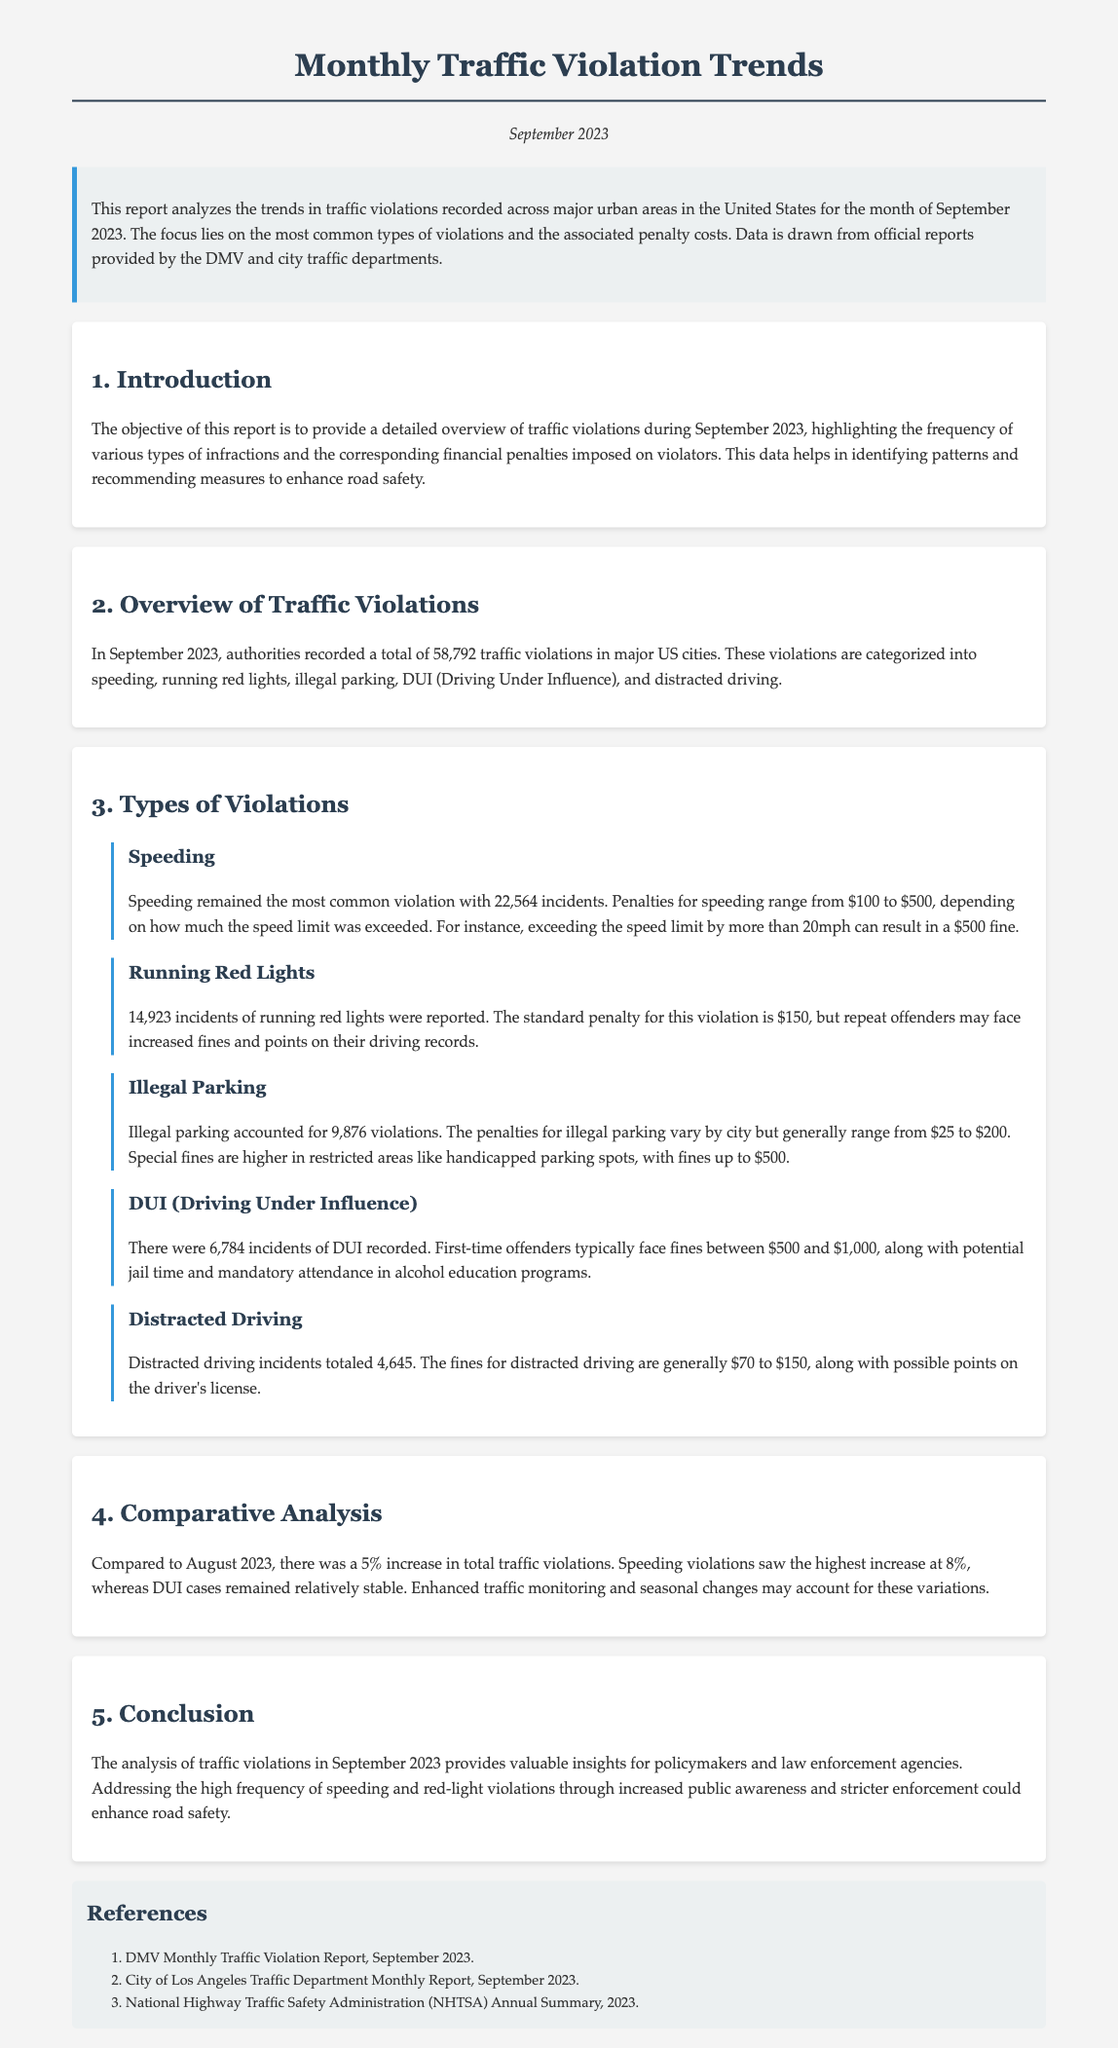What was the total number of traffic violations in September 2023? The total number of traffic violations recorded is stated in the document as 58,792.
Answer: 58,792 How many incidents of DUI were recorded? The document states that there were 6,784 incidents of DUI recorded in September 2023.
Answer: 6,784 What is the penalty range for speeding violations? The document specifies that penalties for speeding range from $100 to $500, depending on how much the speed limit was exceeded.
Answer: $100 to $500 Which type of violation had the highest number of incidents? The document identifies speeding as the most common violation with 22,564 incidents.
Answer: Speeding What percentage increase in total traffic violations was observed compared to August 2023? The report indicates a 5% increase in total traffic violations compared to August 2023.
Answer: 5% What are the penalties for illegal parking? The penalties for illegal parking vary but generally range from $25 to $200, with higher fines in restricted areas.
Answer: $25 to $200 How many incidents of running red lights were reported? The report mentions that there were 14,923 incidents of running red lights recorded.
Answer: 14,923 What specific measure could enhance road safety according to the conclusion? The conclusion suggests that increased public awareness and stricter enforcement could enhance road safety.
Answer: Increased public awareness and stricter enforcement What was the date of the report? The document states that the report is dated September 2023.
Answer: September 2023 